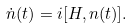Convert formula to latex. <formula><loc_0><loc_0><loc_500><loc_500>\dot { n } ( t ) = i [ H , n ( t ) ] .</formula> 